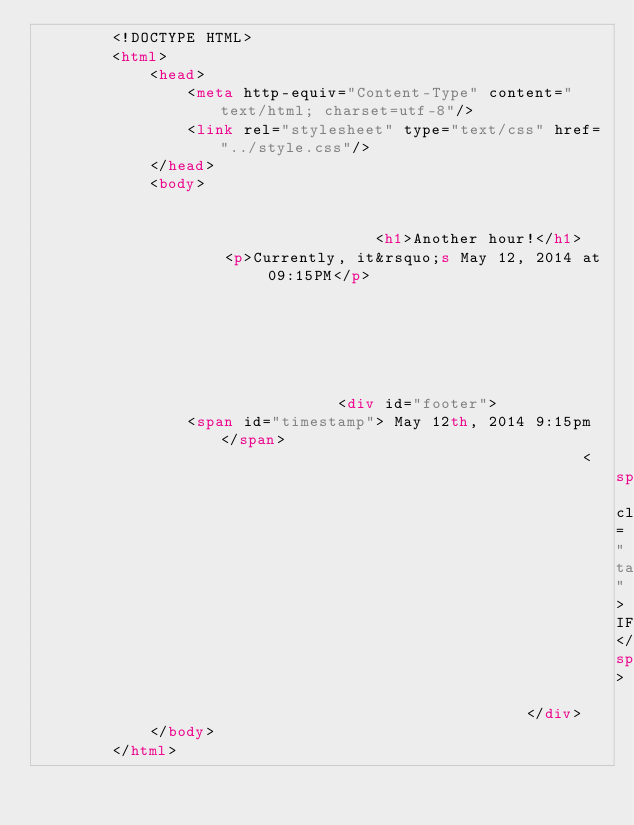<code> <loc_0><loc_0><loc_500><loc_500><_HTML_>        <!DOCTYPE HTML>
        <html>
            <head>
                <meta http-equiv="Content-Type" content="text/html; charset=utf-8"/>
                <link rel="stylesheet" type="text/css" href="../style.css"/>
            </head>
            <body>
                
                
                                    <h1>Another hour!</h1>
                    <p>Currently, it&rsquo;s May 12, 2014 at 09:15PM</p>
                
                
                
                
                
                
                                <div id="footer">
                <span id="timestamp"> May 12th, 2014 9:15pm </span>
                                                          <span class="tag">IFTTT</span>
                                                    </div>
            </body>
        </html>

        </code> 